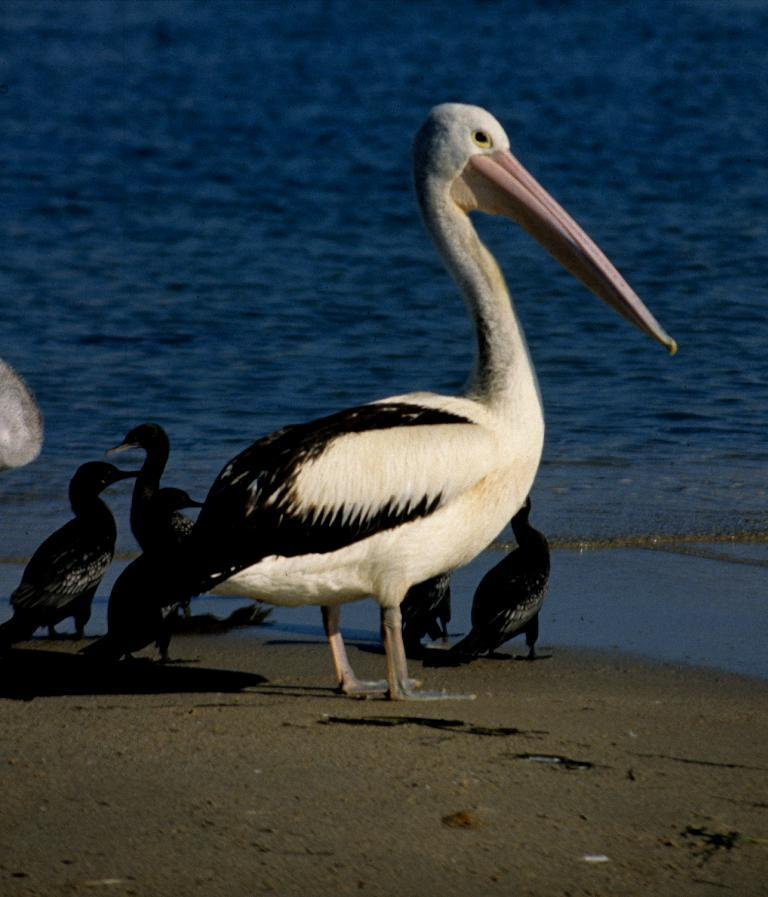What is located in the center of the image? There are birds in the center of the image. What can be seen in the background of the image? There is water visible in the background of the image. What type of terrain is at the bottom of the image? There is sand at the bottom of the image. What type of yak can be seen grazing on the pear in the image? There is no yak or pear present in the image; it features birds and water in the background. 